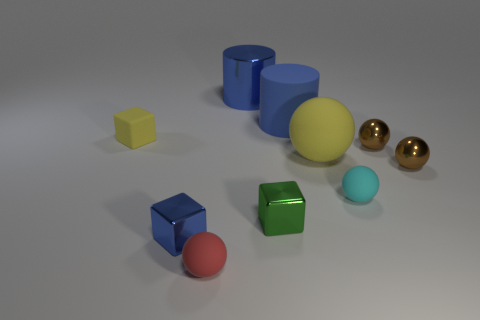Subtract all metallic spheres. How many spheres are left? 3 Subtract all red cubes. How many brown spheres are left? 2 Subtract all yellow spheres. How many spheres are left? 4 Subtract all cylinders. How many objects are left? 8 Add 7 blue blocks. How many blue blocks exist? 8 Subtract 0 purple blocks. How many objects are left? 10 Subtract all yellow cylinders. Subtract all green spheres. How many cylinders are left? 2 Subtract all small cyan spheres. Subtract all small yellow matte things. How many objects are left? 8 Add 7 red objects. How many red objects are left? 8 